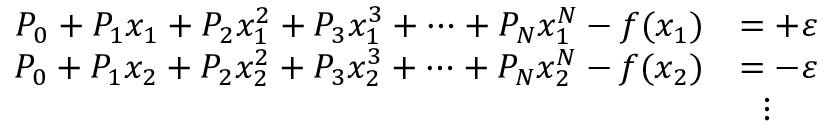<formula> <loc_0><loc_0><loc_500><loc_500>{ \begin{array} { r l } { P _ { 0 } + P _ { 1 } x _ { 1 } + P _ { 2 } x _ { 1 } ^ { 2 } + P _ { 3 } x _ { 1 } ^ { 3 } + \dots + P _ { N } x _ { 1 } ^ { N } - f ( x _ { 1 } ) } & { = + \varepsilon } \\ { P _ { 0 } + P _ { 1 } x _ { 2 } + P _ { 2 } x _ { 2 } ^ { 2 } + P _ { 3 } x _ { 2 } ^ { 3 } + \dots + P _ { N } x _ { 2 } ^ { N } - f ( x _ { 2 } ) } & { = - \varepsilon } \\ & { \quad v d o t s } \end{array} }</formula> 